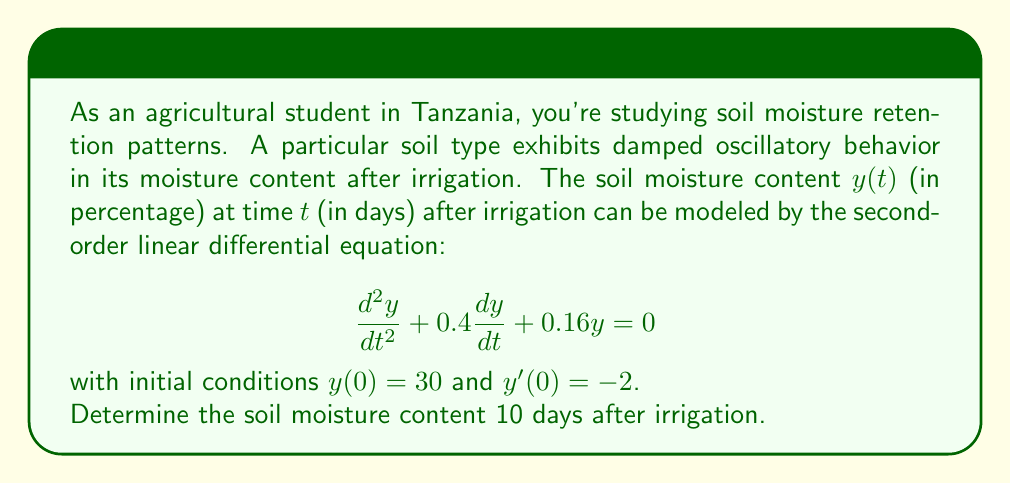Could you help me with this problem? To solve this problem, we'll follow these steps:

1) The given differential equation is in the form of a damped harmonic oscillator:
   $$\frac{d^2y}{dt^2} + 2\beta\frac{dy}{dt} + \omega_0^2y = 0$$
   where $2\beta = 0.4$ and $\omega_0^2 = 0.16$.

2) The general solution for this equation is:
   $$y(t) = e^{-\beta t}(A\cos(\omega t) + B\sin(\omega t))$$
   where $\omega = \sqrt{\omega_0^2 - \beta^2}$.

3) Calculate $\beta$ and $\omega$:
   $\beta = 0.2$ and $\omega = \sqrt{0.16 - 0.04} = \sqrt{0.12} = 2\sqrt{3}/10$.

4) Substitute these values into the general solution:
   $$y(t) = e^{-0.2t}(A\cos(2\sqrt{3}t/10) + B\sin(2\sqrt{3}t/10))$$

5) Use the initial conditions to find A and B:
   $y(0) = 30$, so $A = 30$
   $y'(0) = -2$, so $-0.2A + \frac{2\sqrt{3}}{10}B = -2$
   Solving this, we get $B = 5\sqrt{3}$.

6) The complete solution is:
   $$y(t) = e^{-0.2t}(30\cos(2\sqrt{3}t/10) + 5\sqrt{3}\sin(2\sqrt{3}t/10))$$

7) To find the soil moisture content after 10 days, substitute $t = 10$:
   $$y(10) = e^{-2}(30\cos(2\sqrt{3}) + 5\sqrt{3}\sin(2\sqrt{3}))$$

8) Calculate this value:
   $$y(10) \approx 0.1353 \cdot (30 \cdot (-0.9899) + 5\sqrt{3} \cdot 0.1411) \approx 3.64$$

Therefore, the soil moisture content 10 days after irrigation is approximately 3.64%.
Answer: 3.64% 